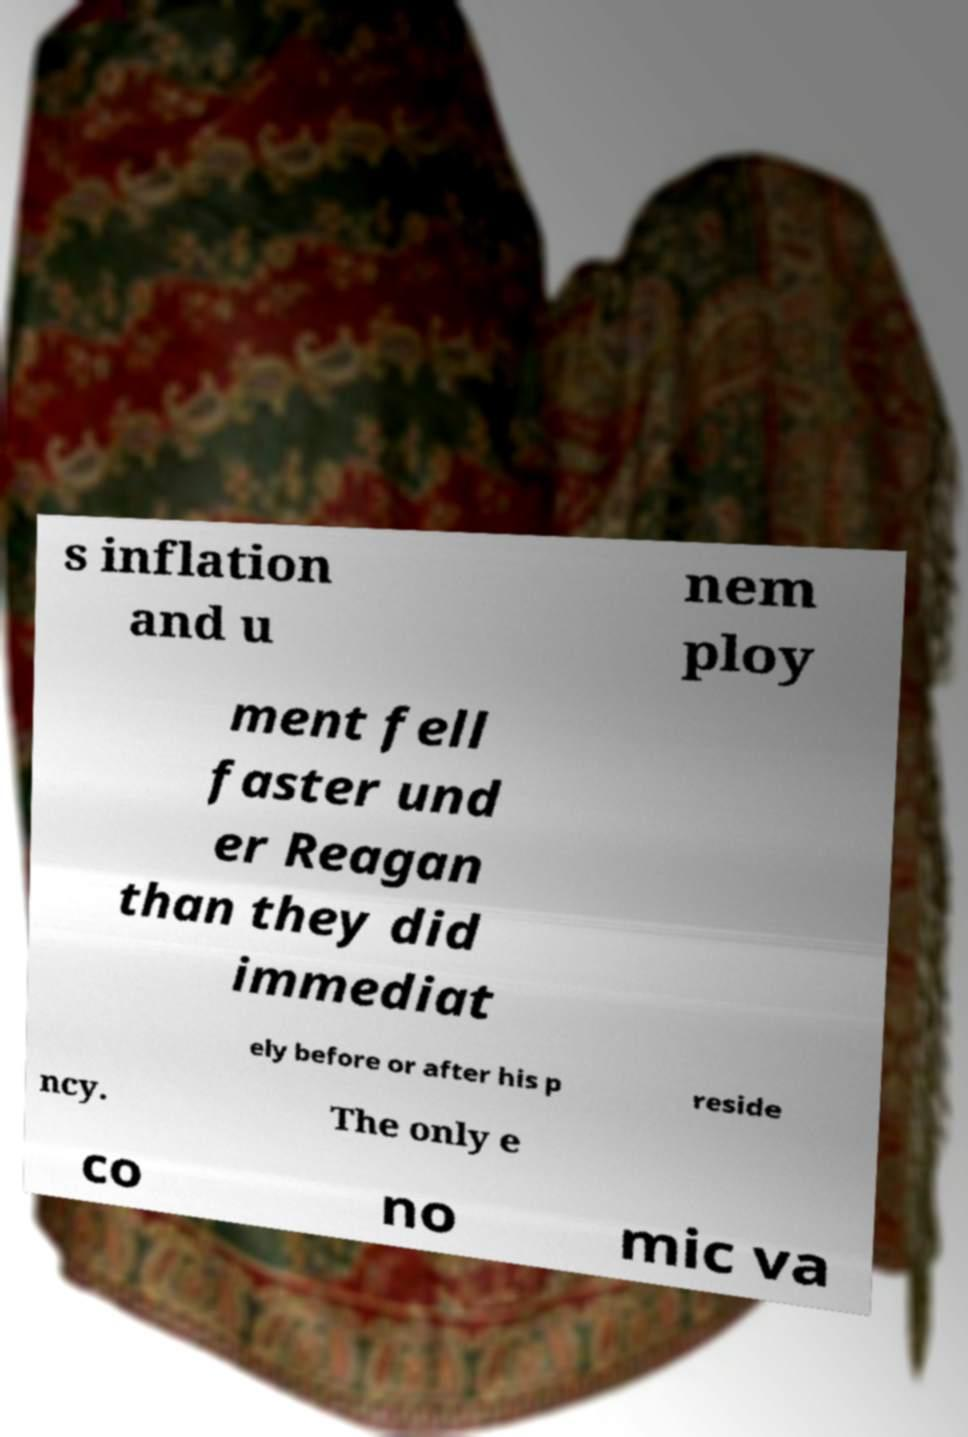Could you assist in decoding the text presented in this image and type it out clearly? s inflation and u nem ploy ment fell faster und er Reagan than they did immediat ely before or after his p reside ncy. The only e co no mic va 